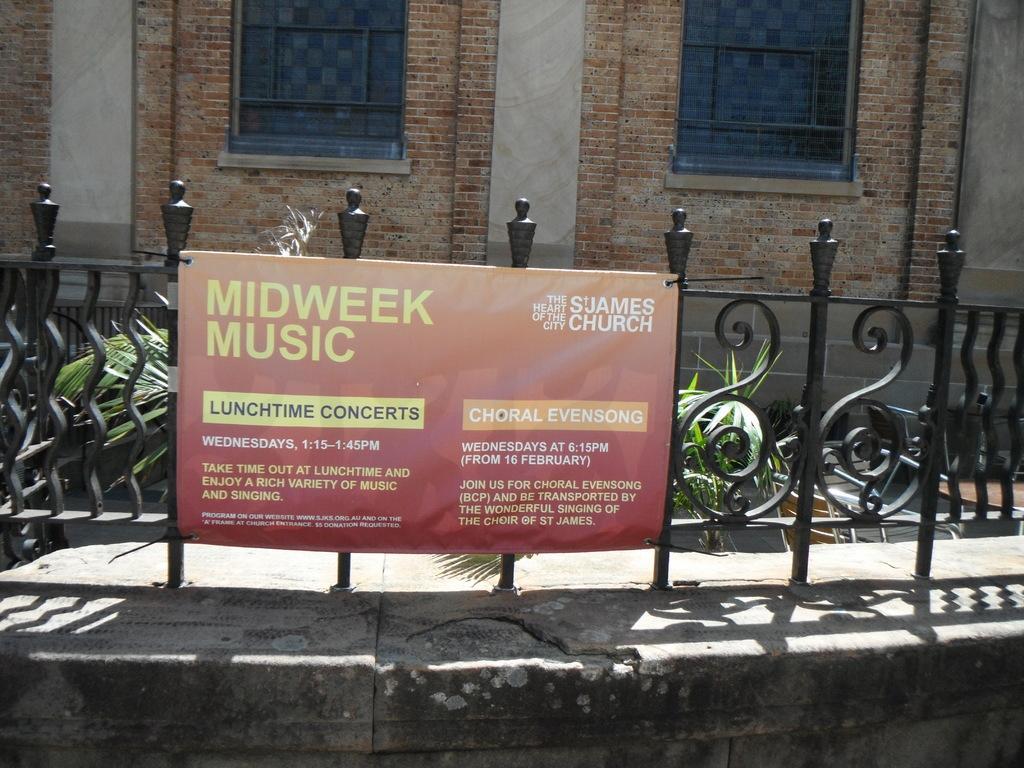Could you give a brief overview of what you see in this image? This image is taken outdoors. In the background there is a building with a wall and windows. There are a few plants. There is a railing. In the middle of the image there is a railing and there is a board with a text on it. At the bottom of the image there is a wall. 